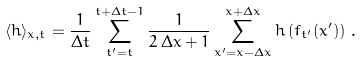<formula> <loc_0><loc_0><loc_500><loc_500>\langle h \rangle _ { x , t } = \frac { 1 } { \Delta t } \sum _ { t ^ { \prime } = t } ^ { t + \Delta t - 1 } \frac { 1 } { 2 \, \Delta x + 1 } \sum _ { x ^ { \prime } = x - \Delta x } ^ { x + \Delta x } h \left ( f _ { t ^ { \prime } } ( x ^ { \prime } ) \right ) \, .</formula> 